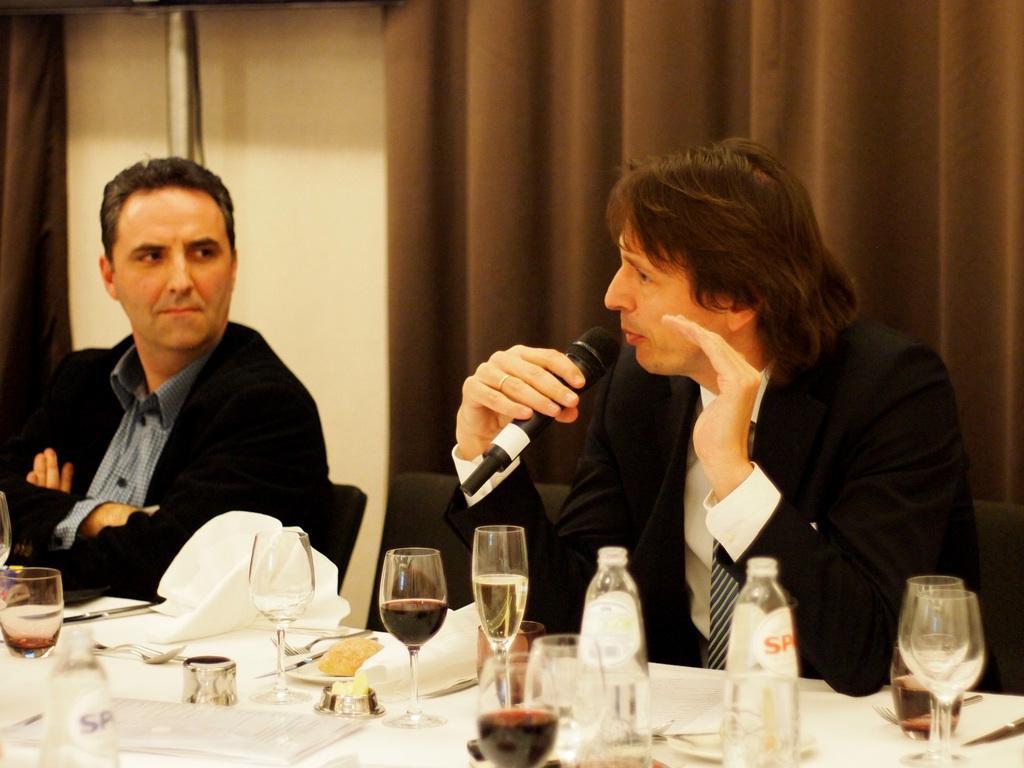Describe this image in one or two sentences. In the image in the center we can see two people were sitting on the chair and the right side person is holding a microphone. In front of them,we can see one table. On the table we can see cloth,tissue paper,wine glasses,bottles,papers and few other objects. In the background there is a wall and curtain. 